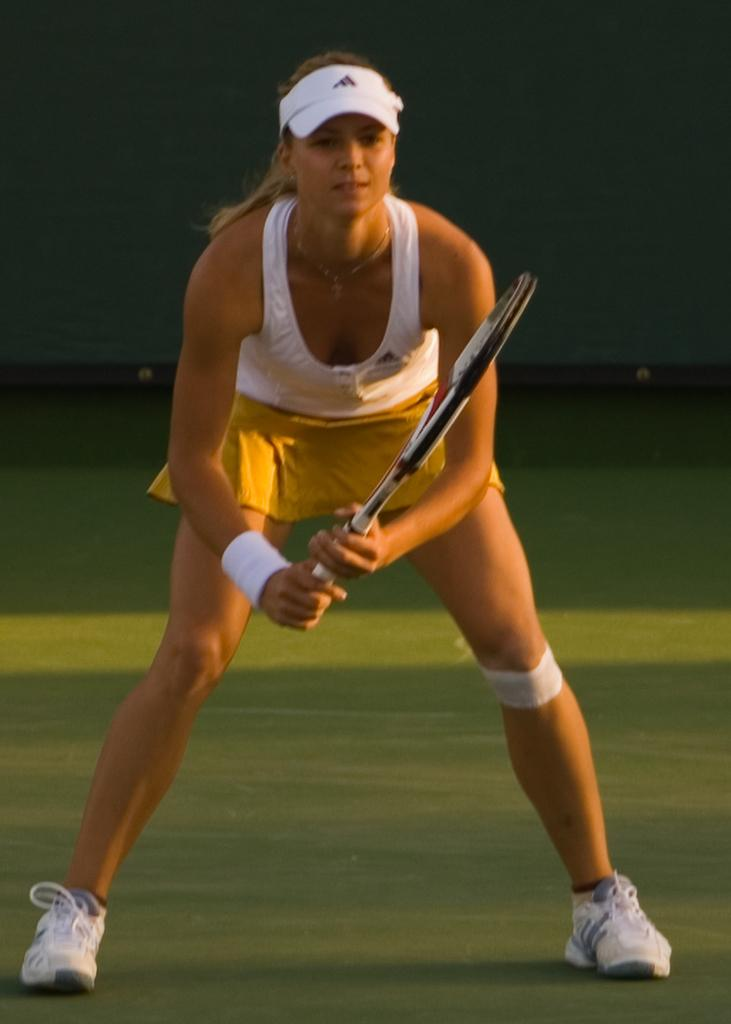What sport is the woman playing in the image? The woman is playing tennis in the image. What color is the top that the woman is wearing? The woman is wearing a white color top. What type of headwear is the woman wearing? The woman is wearing a cap. What color are the shoes that the woman is wearing? The woman is wearing white color shoes. What color are the shorts that the woman is wearing? The woman is wearing a yellow color short. What type of canvas is the woman using to join the tennis match? There is no canvas or joining activity present in the image; the woman is already playing tennis. 